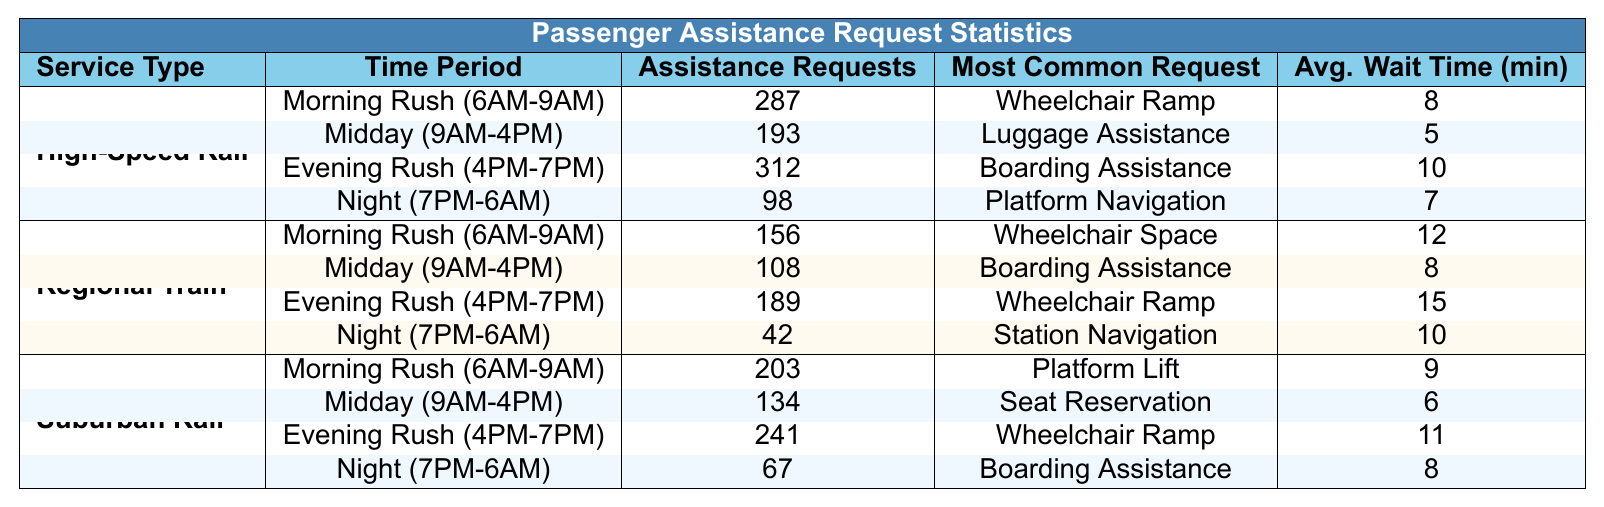What is the most common assistance request during the Evening Rush for High-Speed Rail? According to the table, the most common request during the Evening Rush (4 PM-7 PM) for High-Speed Rail is "Boarding Assistance."
Answer: Boarding Assistance How many assistance requests were made for Suburban Rail during the Night period? The table shows that during the Night period (7 PM-6 AM), there were 67 assistance requests for Suburban Rail.
Answer: 67 What is the average wait time for assistance requests during Midday for Regional Train? From the table, the average wait time during Midday (9 AM-4 PM) for Regional Train is 8 minutes.
Answer: 8 minutes Which service type has the highest number of assistance requests during the Evening Rush? The table indicates that High-Speed Rail has the highest number of assistance requests during the Evening Rush (4 PM-7 PM) with 312 requests.
Answer: High-Speed Rail What is the total number of assistance requests for Suburban Rail during the Morning Rush? The table shows that Suburban Rail had 203 assistance requests during the Morning Rush (6 AM-9 AM).
Answer: 203 Is the average wait time for assistance requests shorter for High-Speed Rail during Midday than for Regional Train during the same period? The average wait time for High-Speed Rail during Midday is 5 minutes while for Regional Train, it is 8 minutes. Since 5 is less than 8, the average wait time for High-Speed Rail is indeed shorter.
Answer: Yes How many more assistance requests were made for High-Speed Rail compared to Regional Train during the Evening Rush? For High-Speed Rail, the number of requests during the Evening Rush was 312, and for Regional Train it was 189. The difference is 312 - 189 = 123.
Answer: 123 Which service type and time period has the highest average wait time? The analysis of the table reveals that the highest average wait time is for Regional Train during the Evening Rush with 15 minutes.
Answer: Regional Train during Evening Rush What was the average number of assistance requests for all service types during Night? The total assistance requests for Night across all service types is 98 (High-Speed Rail) + 42 (Regional Train) + 67 (Suburban Rail) = 207. There are 3 service types, so the average is 207 / 3 = 69.
Answer: 69 Which time period shows the least assistance requests across all service types? By comparing all time periods, the Night period (7 PM-6 AM) for Regional Train has the least requests with only 42.
Answer: Night for Regional Train 